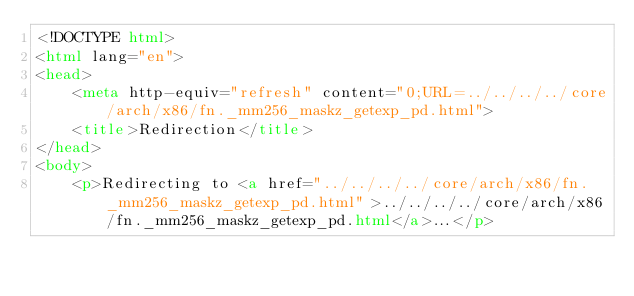Convert code to text. <code><loc_0><loc_0><loc_500><loc_500><_HTML_><!DOCTYPE html>
<html lang="en">
<head>
    <meta http-equiv="refresh" content="0;URL=../../../../core/arch/x86/fn._mm256_maskz_getexp_pd.html">
    <title>Redirection</title>
</head>
<body>
    <p>Redirecting to <a href="../../../../core/arch/x86/fn._mm256_maskz_getexp_pd.html">../../../../core/arch/x86/fn._mm256_maskz_getexp_pd.html</a>...</p></code> 